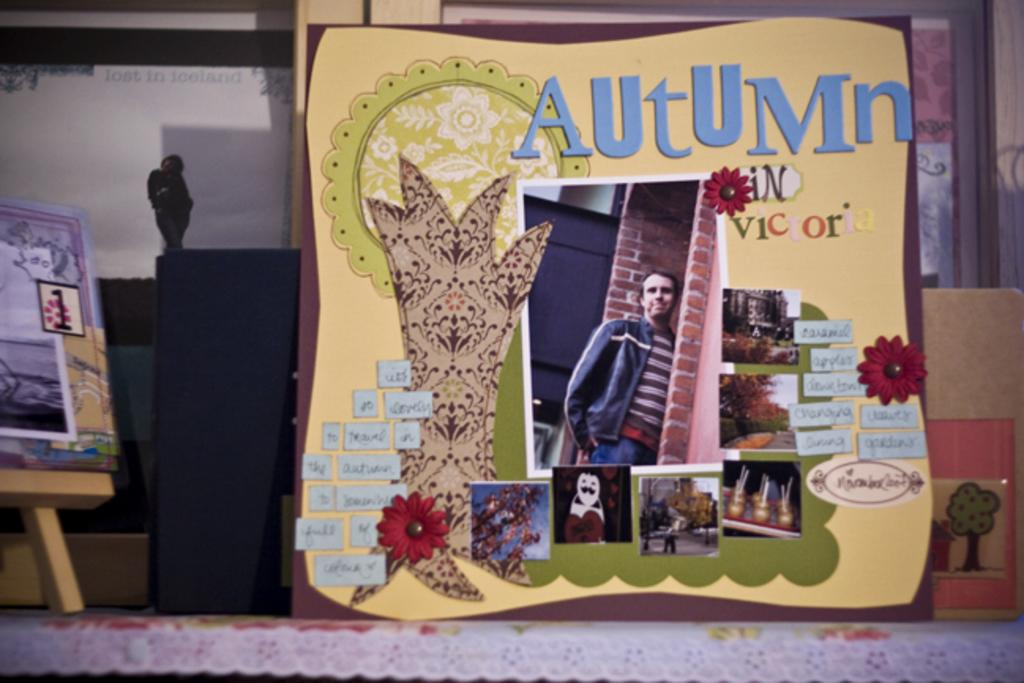Provide a one-sentence caption for the provided image. The season advertised in the card is Autumn. 